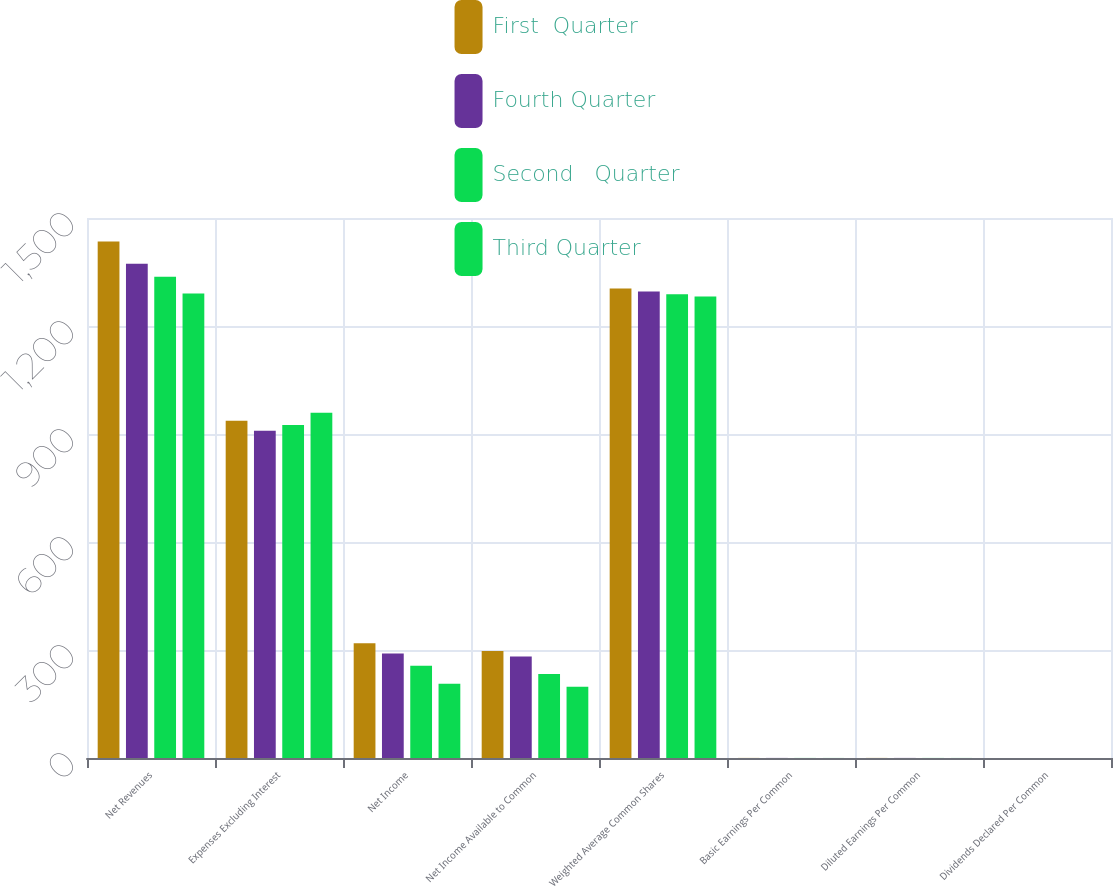Convert chart to OTSL. <chart><loc_0><loc_0><loc_500><loc_500><stacked_bar_chart><ecel><fcel>Net Revenues<fcel>Expenses Excluding Interest<fcel>Net Income<fcel>Net Income Available to Common<fcel>Weighted Average Common Shares<fcel>Basic Earnings Per Common<fcel>Diluted Earnings Per Common<fcel>Dividends Declared Per Common<nl><fcel>First  Quarter<fcel>1435<fcel>937<fcel>319<fcel>297<fcel>1304<fcel>0.23<fcel>0.23<fcel>0.06<nl><fcel>Fourth Quarter<fcel>1373<fcel>909<fcel>290<fcel>282<fcel>1296<fcel>0.22<fcel>0.22<fcel>0.06<nl><fcel>Second   Quarter<fcel>1337<fcel>925<fcel>256<fcel>233<fcel>1288<fcel>0.18<fcel>0.18<fcel>0.06<nl><fcel>Third Quarter<fcel>1290<fcel>959<fcel>206<fcel>198<fcel>1282<fcel>0.15<fcel>0.15<fcel>0.06<nl></chart> 